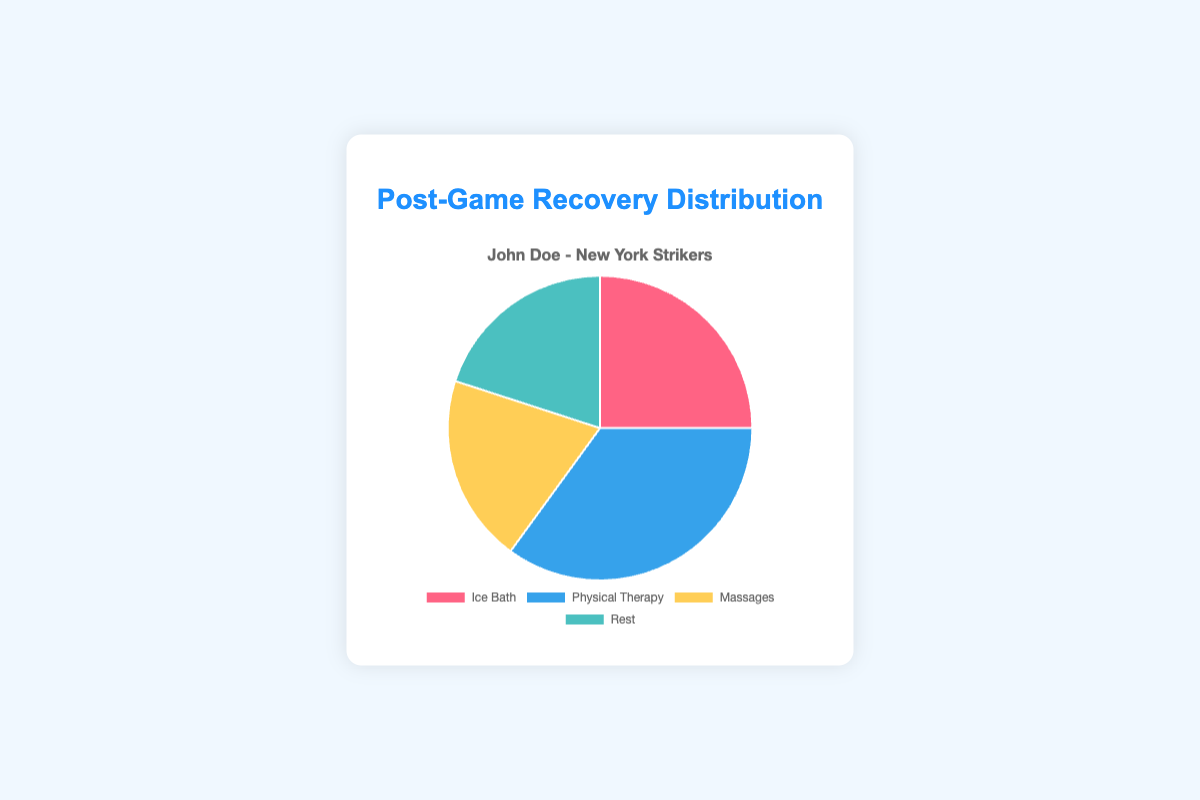Which recovery activity has the highest percentage? By examining the pie chart, it's visible that "Physical Therapy" occupies the largest section of the chart.
Answer: Physical Therapy What is the total percentage of recovery activities that involve direct physical treatment (ice baths and massages)? Adding the percentages for "Ice Bath" (25%) and "Massages" (20%), we get 25 + 20 = 45%.
Answer: 45% How does the percentage of rest compare to the percentage of physical therapy? The percentage of rest (20%) is less than that of physical therapy (35%).
Answer: Less Which activity has an equal percentage representation in the recovery routine? The pie chart shows that "Massages" and "Rest" both have a 20% representation.
Answer: Massages and Rest What fraction of the total recovery time is spent on non-therapeutic activities (rest and massages)? Adding the percentages for "Rest" (20%) and "Massages" (20%) gives 20 + 20 = 40%.
Answer: 40% How much greater is the percentage of physical therapy compared to ice baths? The percentage of physical therapy is 35%, and the percentage of ice baths is 25%. The difference is 35 - 25 = 10%.
Answer: 10% If John Doe wanted to equally distribute his recovery activities, by how much would he need to increase the percentage of massages? For equal distribution among four activities, each should be 25%. The current percentage of massages is 20%. The increase needed is 25 - 20 = 5%.
Answer: 5% What is the average percentage for all recovery activities? Summing up all the percentages (25 + 35 + 20 + 20 = 100) and dividing by the number of activities (4) gives 100 / 4 = 25%.
Answer: 25% Given that the pie chart shows recovery activities using different colors, which activity is represented by the blue segment? By examining the pie chart's legend and colors, the blue segment corresponds to "Physical Therapy".
Answer: Physical Therapy 